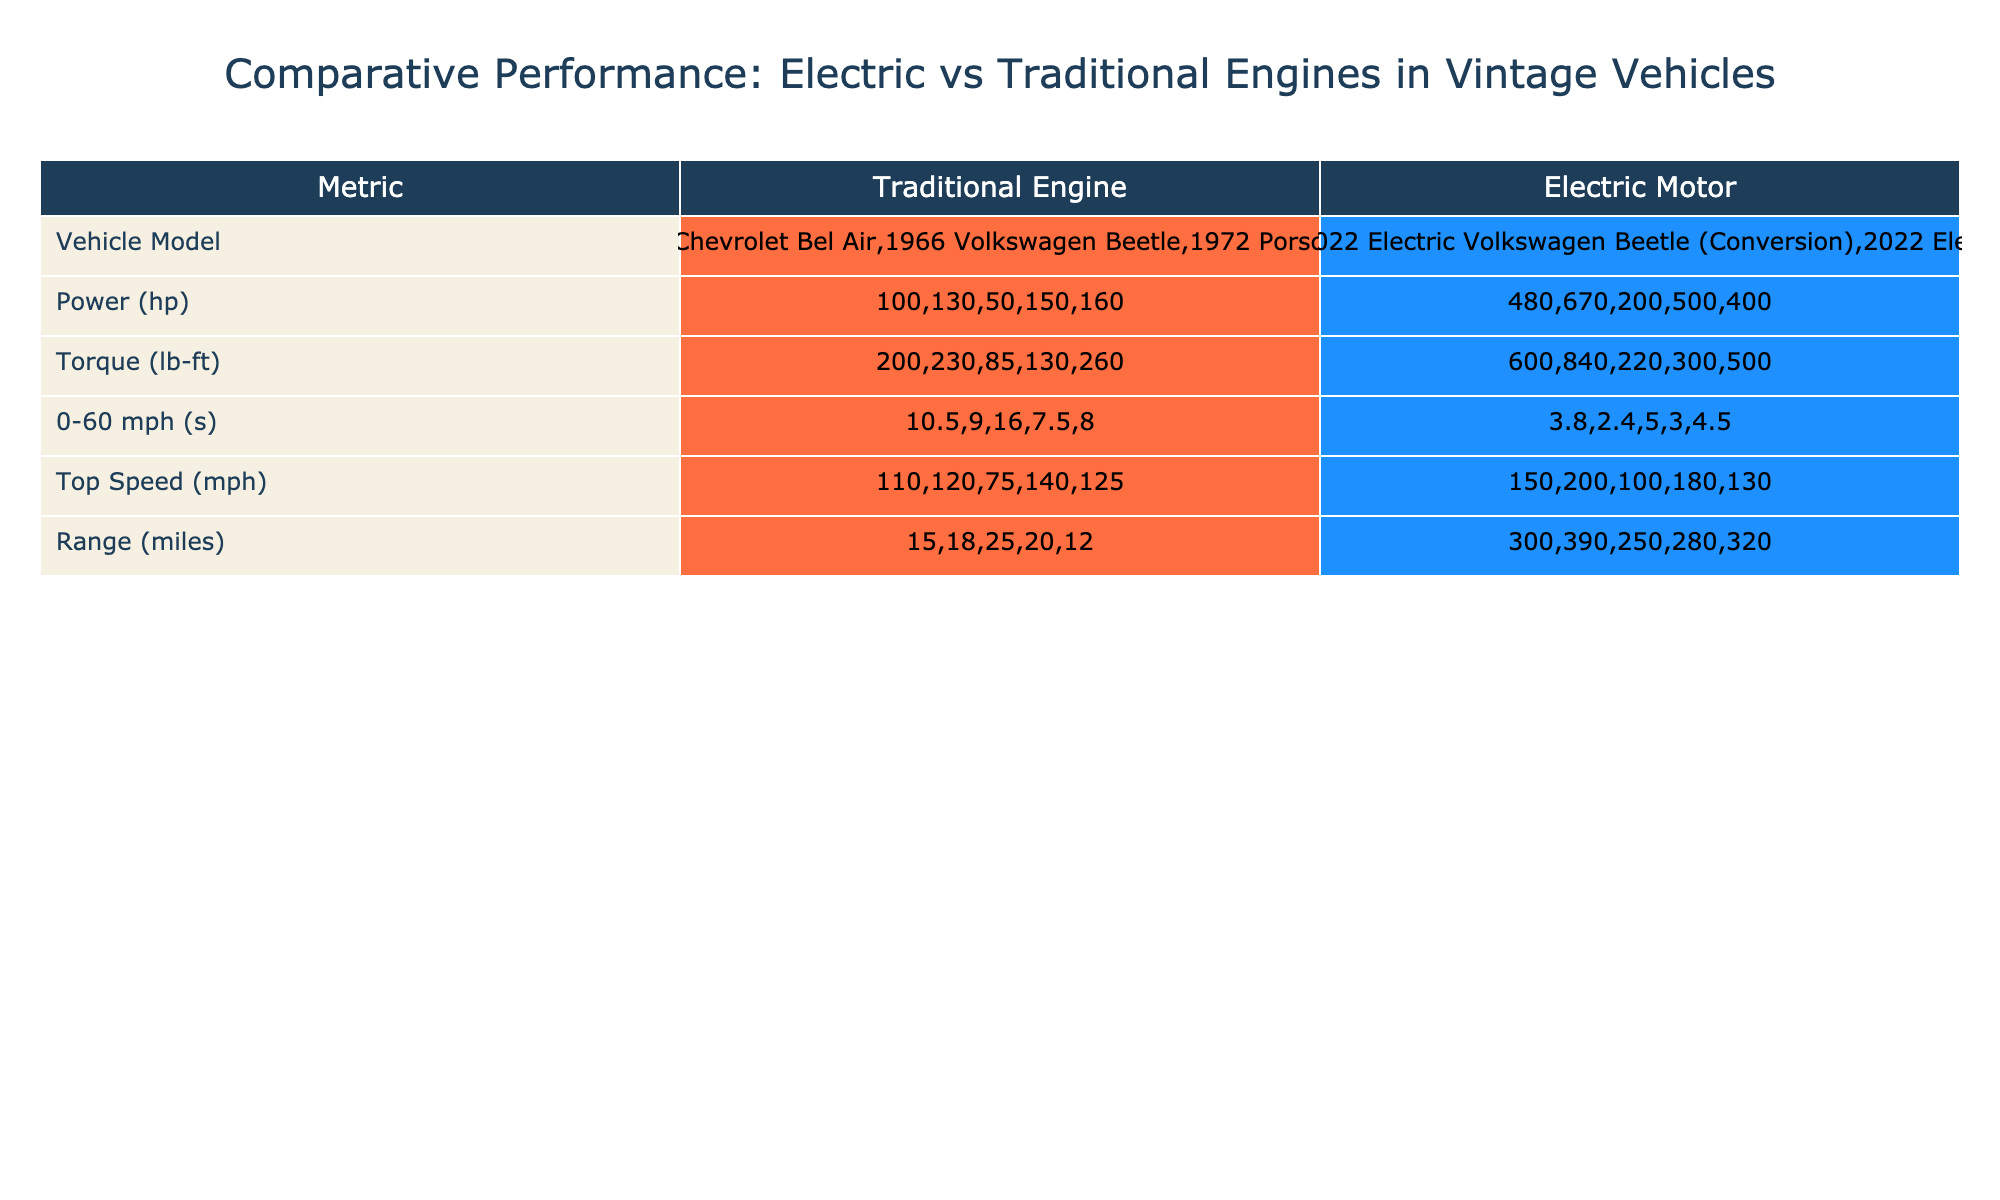What is the power output of the 1955 Chevrolet Bel Air? The table shows that the 1955 Chevrolet Bel Air has a power output of 130 hp in the "Power (hp)" column.
Answer: 130 hp What is the torque of the 2022 Tesla Model S (Conversion)? Referring to the table, the torque for the 2022 Tesla Model S (Conversion) is listed as 840 lb-ft in the "Torque (lb-ft)" column.
Answer: 840 lb-ft Which vehicle has the highest top speed? The table indicates that the 2022 Tesla Model S (Conversion) has the highest top speed at 200 mph, as seen in the "Top Speed (mph)" column.
Answer: 2022 Tesla Model S (Conversion) Which electric vehicle has the longest range, and what is that range? By reviewing the "Range (miles)" column for electric vehicles, the 2022 Tesla Model S (Conversion) has the longest range of 390 miles.
Answer: 2022 Tesla Model S (Conversion), 390 miles What is the average 0-60 mph time for the traditional vehicles? To find the average, we first sum their 0-60 mph times: 10.5 + 9.0 + 16.0 + 7.5 + 8.0 = 51.0 seconds. There are 5 traditional vehicles, so the average is 51.0 / 5 = 10.2 seconds.
Answer: 10.2 seconds Is the torque of the 2022 Electric Porsche 911 (Conversion) greater than that of the 1947 Ford Super Deluxe? The torque of the 2022 Electric Porsche 911 (Conversion) is 300 lb-ft and for the 1947 Ford Super Deluxe, it is 200 lb-ft. Comparing these values, we can conclude that 300 lb-ft is indeed greater than 200 lb-ft.
Answer: Yes What is the difference in power between the strongest electric vehicle and the strongest traditional vehicle? The strongest electric vehicle is the 2022 Tesla Model S (Conversion) with 670 hp, and the strongest traditional vehicle is the 1950 Cadillac Series 62 with 160 hp. The difference is 670 - 160 = 510 hp.
Answer: 510 hp Does every electric vehicle listed have a range greater than 200 miles? Looking at the range of each electric vehicle, 390 miles for the Tesla, 320 miles for the Electric Cadillac, 280 miles for the Electric Porsche, and 250 miles for the Electric Volkswagen Beetle, all of them are indeed greater than 200 miles.
Answer: Yes Which traditional vehicle has the quickest 0-60 mph time? The table indicates that the 1972 Porsche 911 has the quickest 0-60 mph time at 7.5 seconds, as seen in the "0-60 mph (seconds)" column.
Answer: 1972 Porsche 911, 7.5 seconds 